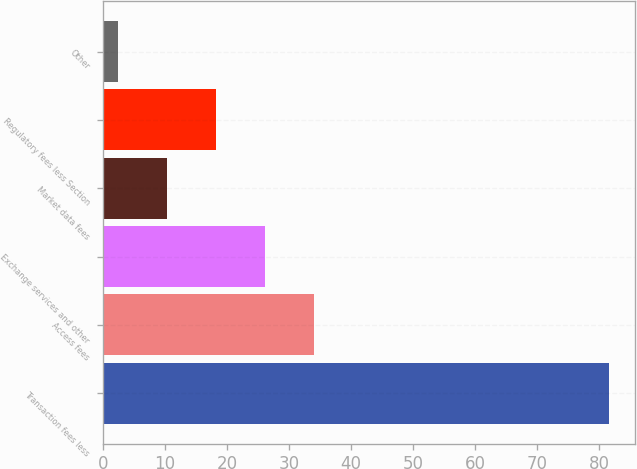<chart> <loc_0><loc_0><loc_500><loc_500><bar_chart><fcel>Transaction fees less<fcel>Access fees<fcel>Exchange services and other<fcel>Market data fees<fcel>Regulatory fees less Section<fcel>Other<nl><fcel>81.6<fcel>34.08<fcel>26.16<fcel>10.32<fcel>18.24<fcel>2.4<nl></chart> 